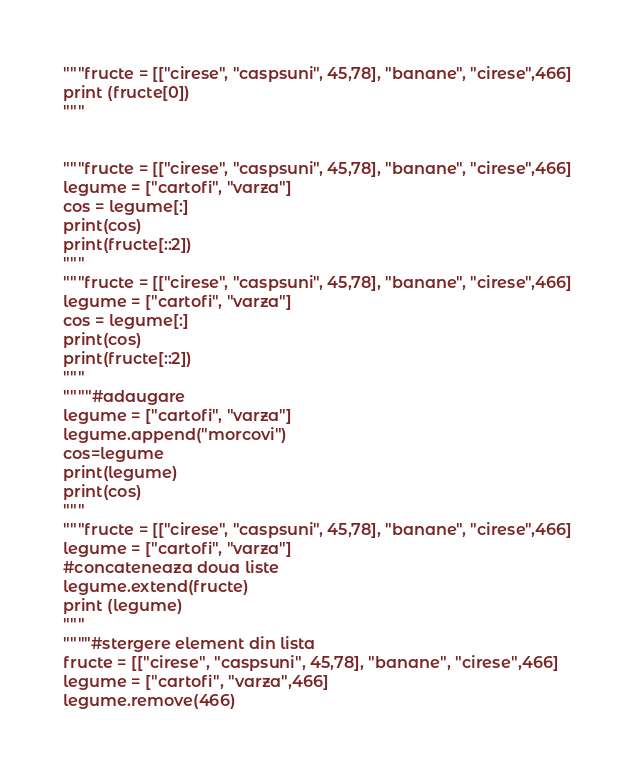Convert code to text. <code><loc_0><loc_0><loc_500><loc_500><_Python_>"""fructe = [["cirese", "caspsuni", 45,78], "banane", "cirese",466]
print (fructe[0])
"""


"""fructe = [["cirese", "caspsuni", 45,78], "banane", "cirese",466]
legume = ["cartofi", "varza"]
cos = legume[:]
print(cos)
print(fructe[::2])
"""
"""fructe = [["cirese", "caspsuni", 45,78], "banane", "cirese",466]
legume = ["cartofi", "varza"]
cos = legume[:]
print(cos)
print(fructe[::2])
"""
""""#adaugare
legume = ["cartofi", "varza"]
legume.append("morcovi")
cos=legume
print(legume)
print(cos)
"""
"""fructe = [["cirese", "caspsuni", 45,78], "banane", "cirese",466]
legume = ["cartofi", "varza"]
#concateneaza doua liste
legume.extend(fructe)
print (legume)
"""
""""#stergere element din lista
fructe = [["cirese", "caspsuni", 45,78], "banane", "cirese",466]
legume = ["cartofi", "varza",466]
legume.remove(466)</code> 